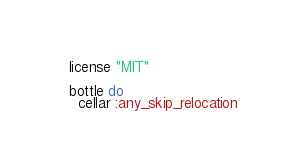Convert code to text. <code><loc_0><loc_0><loc_500><loc_500><_Ruby_>  license "MIT"

  bottle do
    cellar :any_skip_relocation</code> 